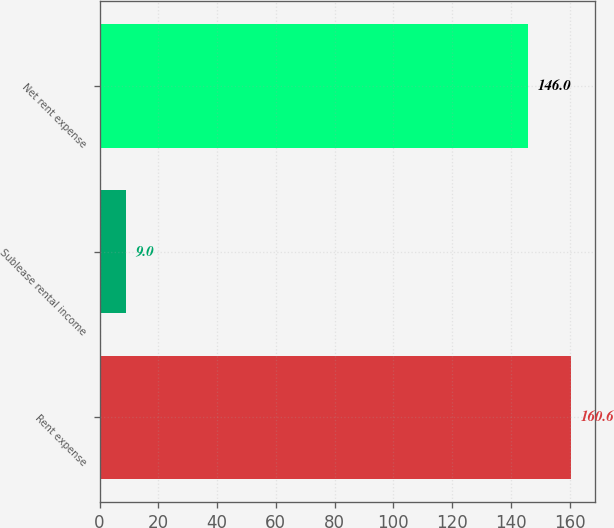<chart> <loc_0><loc_0><loc_500><loc_500><bar_chart><fcel>Rent expense<fcel>Sublease rental income<fcel>Net rent expense<nl><fcel>160.6<fcel>9<fcel>146<nl></chart> 